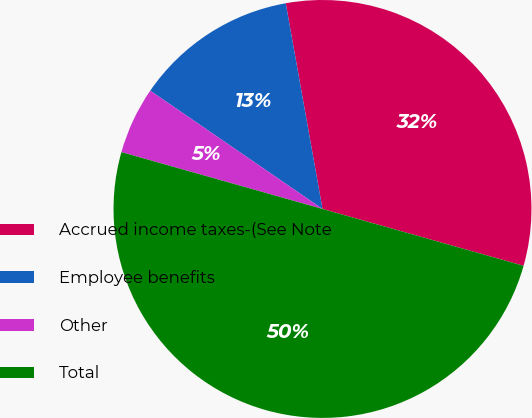Convert chart. <chart><loc_0><loc_0><loc_500><loc_500><pie_chart><fcel>Accrued income taxes-(See Note<fcel>Employee benefits<fcel>Other<fcel>Total<nl><fcel>32.2%<fcel>12.61%<fcel>5.19%<fcel>50.0%<nl></chart> 